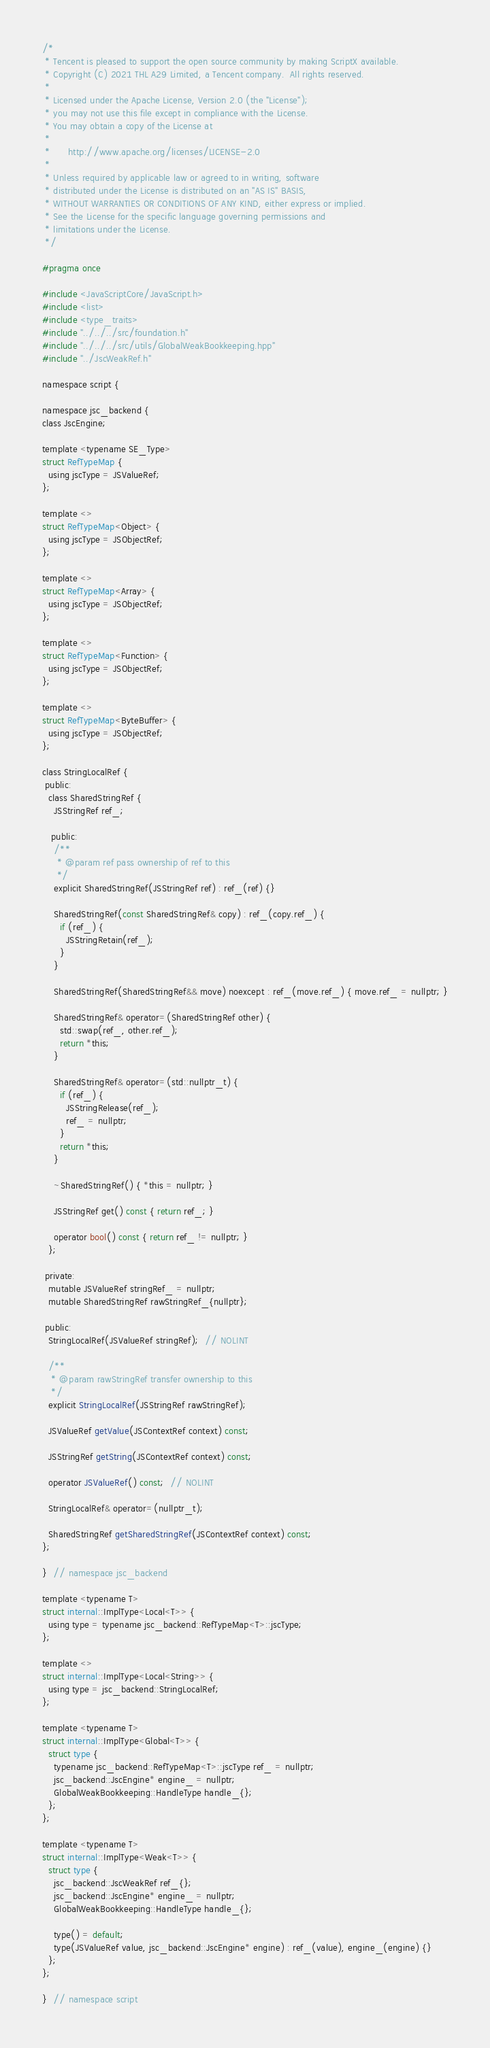<code> <loc_0><loc_0><loc_500><loc_500><_C_>/*
 * Tencent is pleased to support the open source community by making ScriptX available.
 * Copyright (C) 2021 THL A29 Limited, a Tencent company.  All rights reserved.
 *
 * Licensed under the Apache License, Version 2.0 (the "License");
 * you may not use this file except in compliance with the License.
 * You may obtain a copy of the License at
 *
 *      http://www.apache.org/licenses/LICENSE-2.0
 *
 * Unless required by applicable law or agreed to in writing, software
 * distributed under the License is distributed on an "AS IS" BASIS,
 * WITHOUT WARRANTIES OR CONDITIONS OF ANY KIND, either express or implied.
 * See the License for the specific language governing permissions and
 * limitations under the License.
 */

#pragma once

#include <JavaScriptCore/JavaScript.h>
#include <list>
#include <type_traits>
#include "../../../src/foundation.h"
#include "../../../src/utils/GlobalWeakBookkeeping.hpp"
#include "../JscWeakRef.h"

namespace script {

namespace jsc_backend {
class JscEngine;

template <typename SE_Type>
struct RefTypeMap {
  using jscType = JSValueRef;
};

template <>
struct RefTypeMap<Object> {
  using jscType = JSObjectRef;
};

template <>
struct RefTypeMap<Array> {
  using jscType = JSObjectRef;
};

template <>
struct RefTypeMap<Function> {
  using jscType = JSObjectRef;
};

template <>
struct RefTypeMap<ByteBuffer> {
  using jscType = JSObjectRef;
};

class StringLocalRef {
 public:
  class SharedStringRef {
    JSStringRef ref_;

   public:
    /**
     * @param ref pass ownership of ref to this
     */
    explicit SharedStringRef(JSStringRef ref) : ref_(ref) {}

    SharedStringRef(const SharedStringRef& copy) : ref_(copy.ref_) {
      if (ref_) {
        JSStringRetain(ref_);
      }
    }

    SharedStringRef(SharedStringRef&& move) noexcept : ref_(move.ref_) { move.ref_ = nullptr; }

    SharedStringRef& operator=(SharedStringRef other) {
      std::swap(ref_, other.ref_);
      return *this;
    }

    SharedStringRef& operator=(std::nullptr_t) {
      if (ref_) {
        JSStringRelease(ref_);
        ref_ = nullptr;
      }
      return *this;
    }

    ~SharedStringRef() { *this = nullptr; }

    JSStringRef get() const { return ref_; }

    operator bool() const { return ref_ != nullptr; }
  };

 private:
  mutable JSValueRef stringRef_ = nullptr;
  mutable SharedStringRef rawStringRef_{nullptr};

 public:
  StringLocalRef(JSValueRef stringRef);  // NOLINT

  /**
   * @param rawStringRef transfer ownership to this
   */
  explicit StringLocalRef(JSStringRef rawStringRef);

  JSValueRef getValue(JSContextRef context) const;

  JSStringRef getString(JSContextRef context) const;

  operator JSValueRef() const;  // NOLINT

  StringLocalRef& operator=(nullptr_t);

  SharedStringRef getSharedStringRef(JSContextRef context) const;
};

}  // namespace jsc_backend

template <typename T>
struct internal::ImplType<Local<T>> {
  using type = typename jsc_backend::RefTypeMap<T>::jscType;
};

template <>
struct internal::ImplType<Local<String>> {
  using type = jsc_backend::StringLocalRef;
};

template <typename T>
struct internal::ImplType<Global<T>> {
  struct type {
    typename jsc_backend::RefTypeMap<T>::jscType ref_ = nullptr;
    jsc_backend::JscEngine* engine_ = nullptr;
    GlobalWeakBookkeeping::HandleType handle_{};
  };
};

template <typename T>
struct internal::ImplType<Weak<T>> {
  struct type {
    jsc_backend::JscWeakRef ref_{};
    jsc_backend::JscEngine* engine_ = nullptr;
    GlobalWeakBookkeeping::HandleType handle_{};

    type() = default;
    type(JSValueRef value, jsc_backend::JscEngine* engine) : ref_(value), engine_(engine) {}
  };
};

}  // namespace script
</code> 